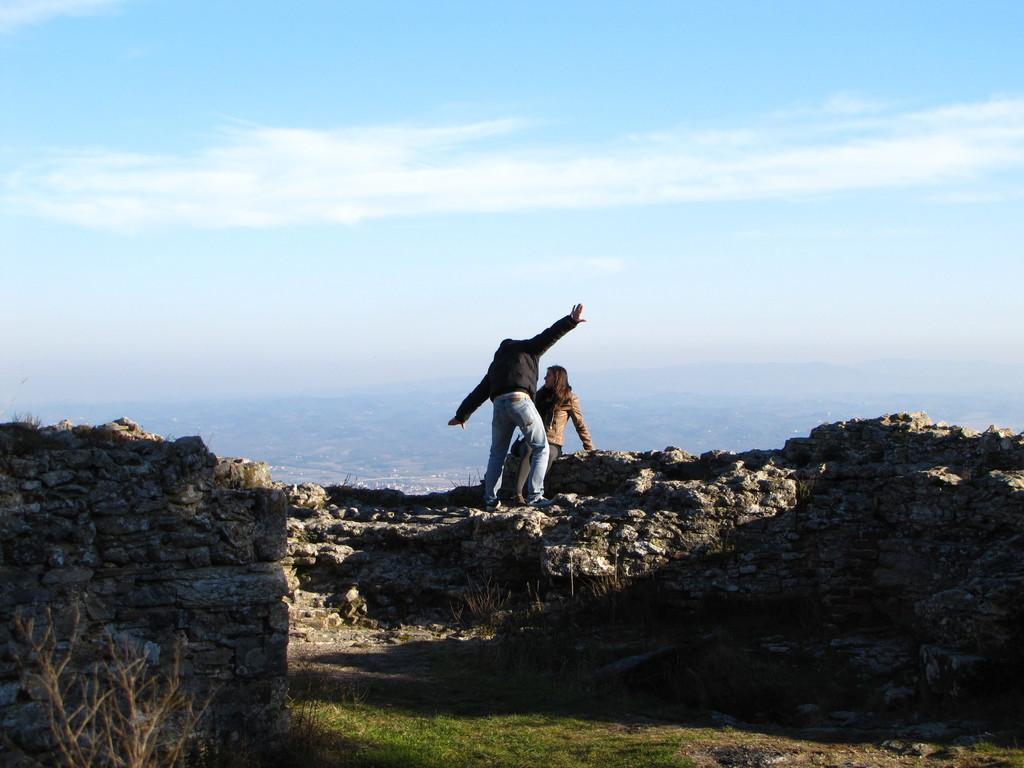What is the person in the image doing? There is a person sitting on a rock in the image, and another person standing. What can be seen in the background of the image? There is a wall in the image, as well as a plant and grass. What is the condition of the sky in the image? The sky is cloudy in the image. What type of yam is being used as a prop in the image? There is no yam present in the image; it features a person sitting on a rock and another standing, along with a wall, plant, grass, and a cloudy sky. 